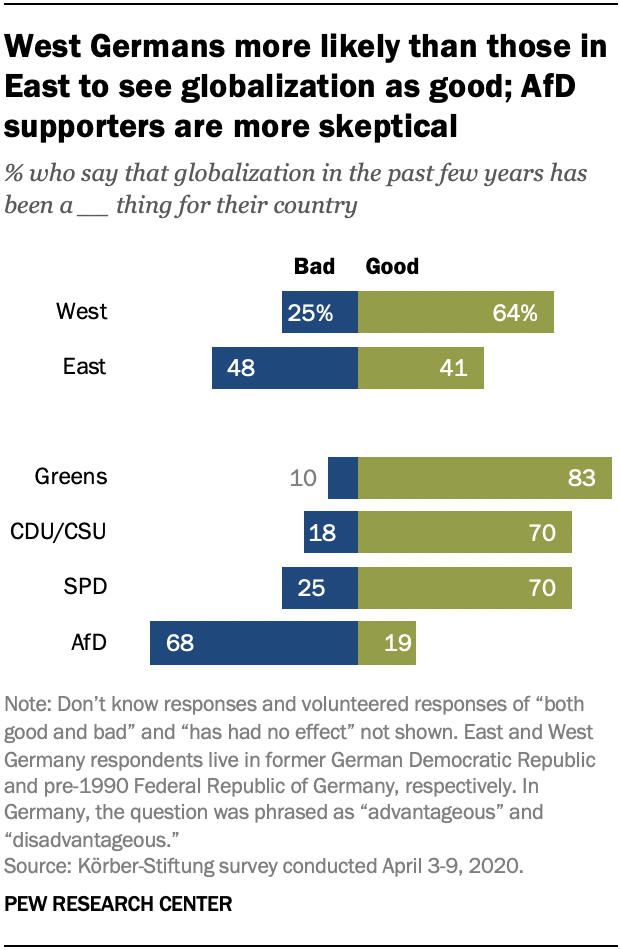Highlight a few significant elements in this photo. The color of the bar is green, and its value for East 41 is yes. Out of the values in the green bars, how many are the same? 